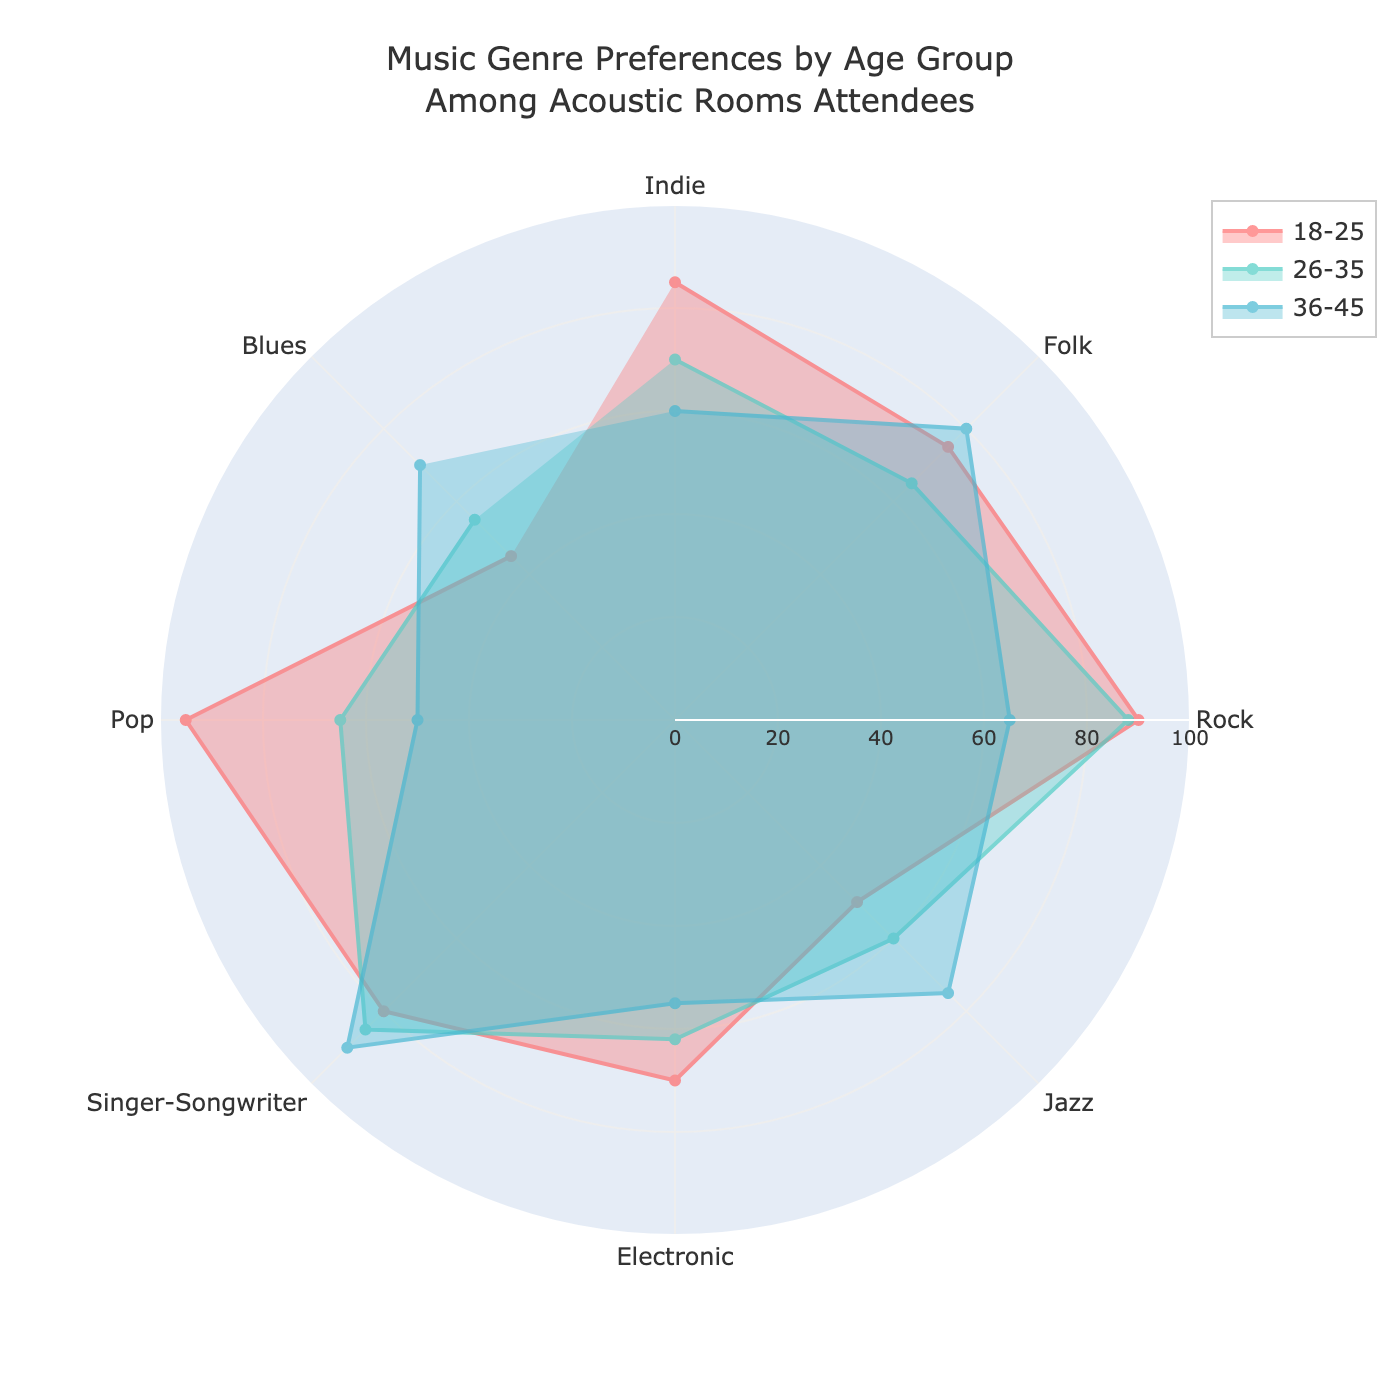What is the title of the radar chart? The title is usually found at the top of the chart and provides a brief description of what the chart is about. In this case, the title is "Music Genre Preferences by Age Group Among Acoustic Rooms Attendees".
Answer: Music Genre Preferences by Age Group Among Acoustic Rooms Attendees Which age group has the highest preference for Rock music? By looking at the point corresponding to Rock music along the radial line for each age group, you can see that the 18-25 age group has the highest value at 90.
Answer: 18-25 What is the lowest preference shown for any genre by any age group? Scan through each segment for all age groups to find the lowest value, which is found in the Blues category for the 18-25 age group, with a value of 45.
Answer: 45 Which music genre has the smallest range of preferences across all age groups? Calculate the range (difference between maximum and minimum values) for each genre. Jazz has a range of 25 (75-50), which is smaller than other genres.
Answer: Jazz How does the 26-35 age group’s preference for Electronic music compare to the 36-45 age group’s preference for the same genre? Look at the radial value for Electronic music under both 26-35 and 36-45 age groups. The 26-35 age group has a value of 62, while the 36-45 age group has a value of 55. Thus, the 26-35 age group has a higher preference.
Answer: Higher for 26-35 Which music genre is preferred almost equally by the 18-25 and 26-35 age groups? Compare the values of the music genres for both age groups and find genres where the values are close. For Electronic music, the 18-25 group has 70 and the 26-35 group has 62, which are quite close.
Answer: Electronic What is the average preference for Folk music across all age groups? Add up the preferences for Folk music for all age groups (75 for 18-25, 65 for 26-35, and 80 for 36-45), then divide by the number of age groups (3). (75 + 65 + 80) / 3 = 73.33
Answer: 73.33 Are there any genres where the 36-45 age group has the highest preference compared to the other age groups? Compare the values for each genre for the 36-45 age group with the other age groups. For Singer-Songwriter, the 36-45 group has a value of 90, which is higher than the other groups.
Answer: Singer-Songwriter What is the total preference for Pop music across all age groups? Add the values for Pop music for all age groups: 95 (18-25) + 65 (26-35) + 50 (36-45). The total is 210.
Answer: 210 